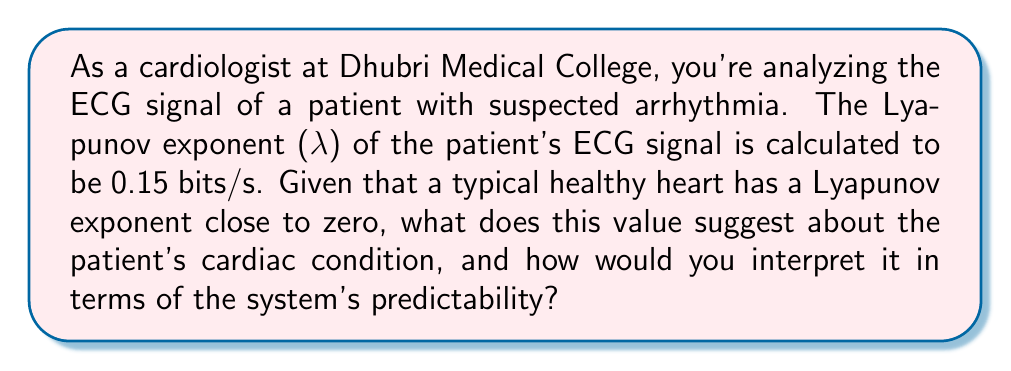Show me your answer to this math problem. To interpret the Lyapunov exponent (λ) of the patient's ECG signal, we need to understand its significance in chaos theory:

1. The Lyapunov exponent quantifies the rate of separation of infinitesimally close trajectories in a dynamical system. In the context of ECG signals, it measures the predictability and stability of the heart's electrical activity.

2. Interpretation of λ values:
   - λ < 0: The system is stable and predictable
   - λ = 0: The system is in a steady state or periodic
   - λ > 0: The system exhibits chaotic behavior

3. For this patient, λ = 0.15 bits/s, which is greater than zero.

4. This positive value indicates that the patient's ECG signal shows some degree of chaotic behavior.

5. To quantify the predictability, we can calculate the Lyapunov time (τ), which is the time horizon for reliable predictions:

   $$τ = \frac{1}{λ} = \frac{1}{0.15} ≈ 6.67 \text{ seconds}$$

6. This means that beyond about 6.67 seconds, the ECG signal becomes increasingly difficult to predict accurately.

7. In the context of cardiac health:
   - A healthy heart typically has a Lyapunov exponent close to zero, indicating a balance between stability and adaptability.
   - The positive λ value suggests increased irregularity in the patient's heart rhythm, which could be indicative of arrhythmia or other cardiac abnormalities.

8. However, some degree of chaos is normal and even necessary for a healthy cardiovascular system to adapt to changing demands.

9. The moderate value of 0.15 bits/s suggests a mild to moderate increase in cardiac irregularity, which warrants further investigation but may not necessarily indicate severe pathology.
Answer: The Lyapunov exponent of 0.15 bits/s indicates mild to moderate cardiac irregularity, suggesting possible arrhythmia. The system becomes unpredictable beyond ~6.67 seconds. 